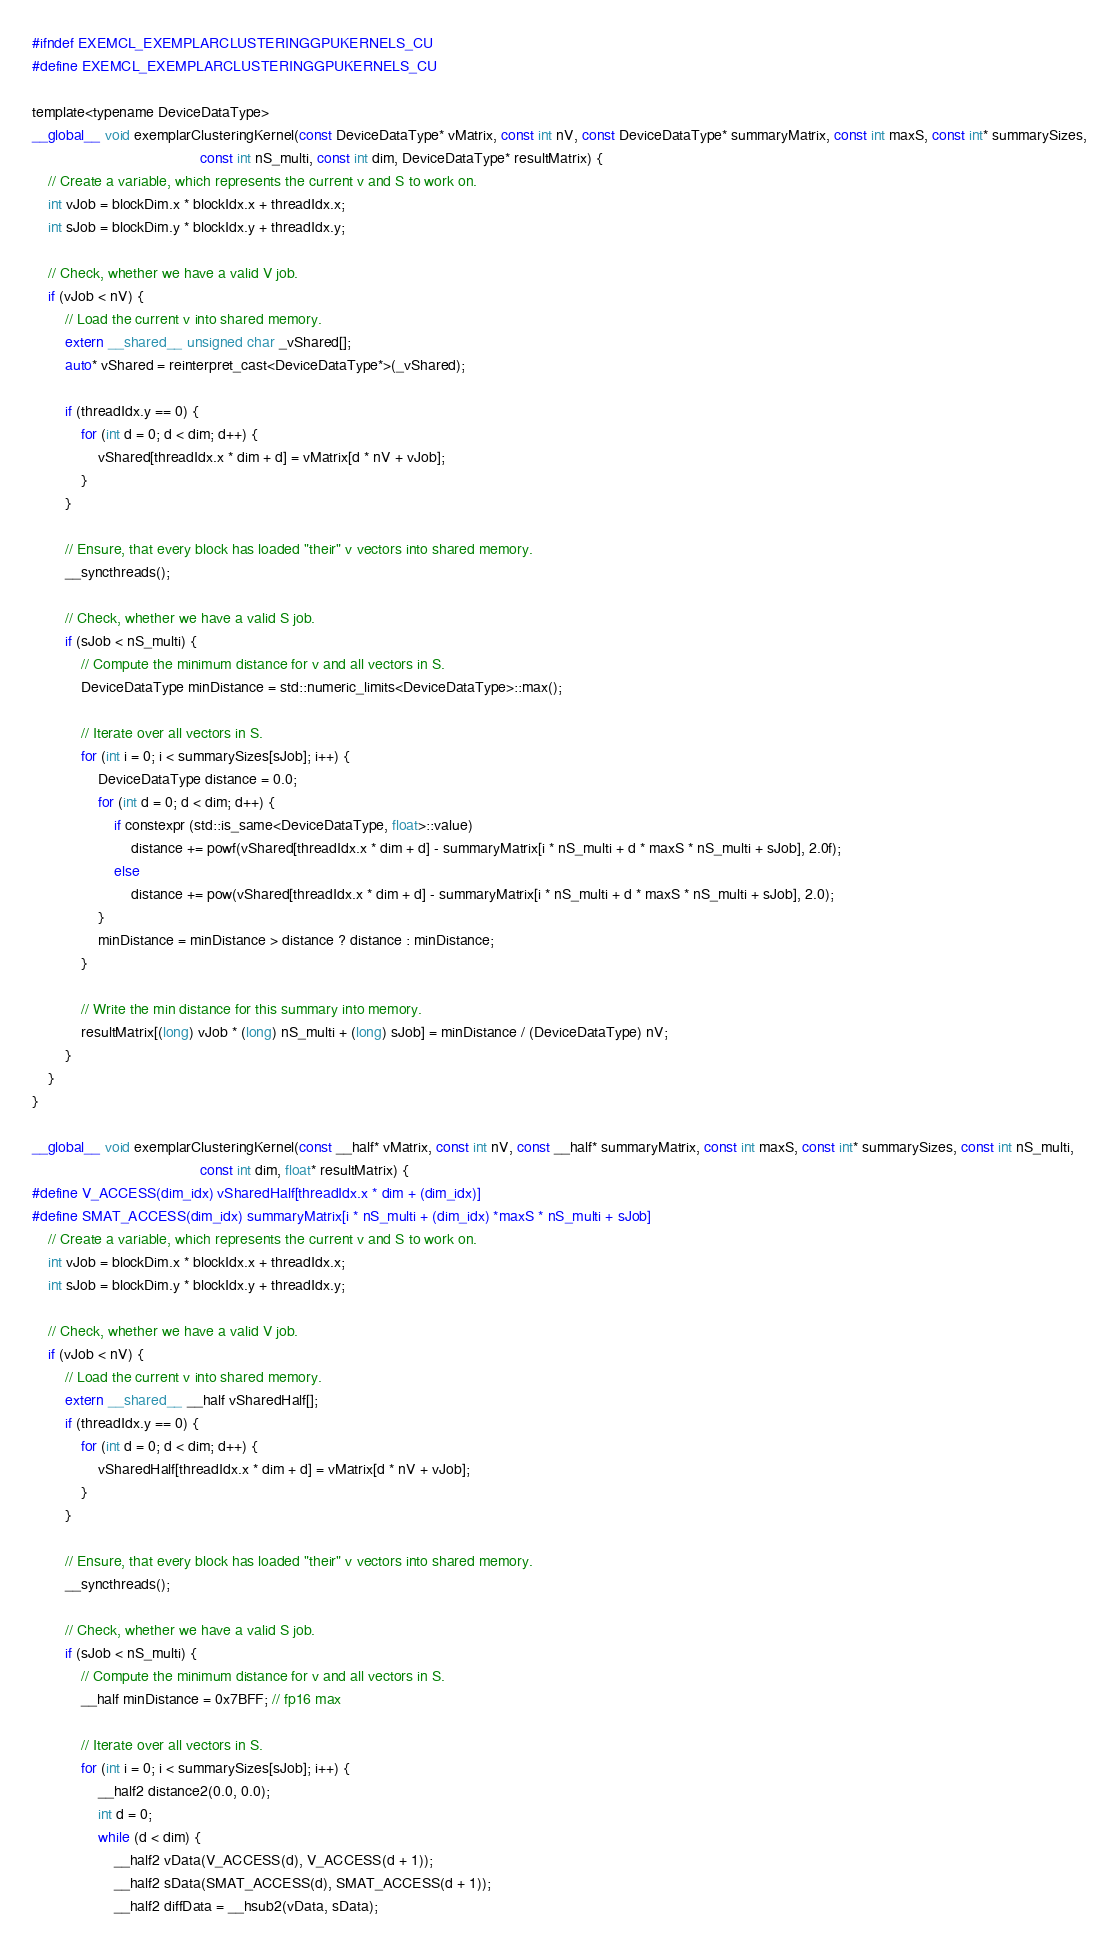<code> <loc_0><loc_0><loc_500><loc_500><_Cuda_>#ifndef EXEMCL_EXEMPLARCLUSTERINGGPUKERNELS_CU
#define EXEMCL_EXEMPLARCLUSTERINGGPUKERNELS_CU

template<typename DeviceDataType>
__global__ void exemplarClusteringKernel(const DeviceDataType* vMatrix, const int nV, const DeviceDataType* summaryMatrix, const int maxS, const int* summarySizes,
                                         const int nS_multi, const int dim, DeviceDataType* resultMatrix) {
    // Create a variable, which represents the current v and S to work on.
    int vJob = blockDim.x * blockIdx.x + threadIdx.x;
    int sJob = blockDim.y * blockIdx.y + threadIdx.y;

    // Check, whether we have a valid V job.
    if (vJob < nV) {
        // Load the current v into shared memory.
        extern __shared__ unsigned char _vShared[];
        auto* vShared = reinterpret_cast<DeviceDataType*>(_vShared);

        if (threadIdx.y == 0) {
            for (int d = 0; d < dim; d++) {
                vShared[threadIdx.x * dim + d] = vMatrix[d * nV + vJob];
            }
        }

        // Ensure, that every block has loaded "their" v vectors into shared memory.
        __syncthreads();

        // Check, whether we have a valid S job.
        if (sJob < nS_multi) {
            // Compute the minimum distance for v and all vectors in S.
            DeviceDataType minDistance = std::numeric_limits<DeviceDataType>::max();

            // Iterate over all vectors in S.
            for (int i = 0; i < summarySizes[sJob]; i++) {
                DeviceDataType distance = 0.0;
                for (int d = 0; d < dim; d++) {
                    if constexpr (std::is_same<DeviceDataType, float>::value)
                        distance += powf(vShared[threadIdx.x * dim + d] - summaryMatrix[i * nS_multi + d * maxS * nS_multi + sJob], 2.0f);
                    else
                        distance += pow(vShared[threadIdx.x * dim + d] - summaryMatrix[i * nS_multi + d * maxS * nS_multi + sJob], 2.0);
                }
                minDistance = minDistance > distance ? distance : minDistance;
            }

            // Write the min distance for this summary into memory.
            resultMatrix[(long) vJob * (long) nS_multi + (long) sJob] = minDistance / (DeviceDataType) nV;
        }
    }
}

__global__ void exemplarClusteringKernel(const __half* vMatrix, const int nV, const __half* summaryMatrix, const int maxS, const int* summarySizes, const int nS_multi,
                                         const int dim, float* resultMatrix) {
#define V_ACCESS(dim_idx) vSharedHalf[threadIdx.x * dim + (dim_idx)]
#define SMAT_ACCESS(dim_idx) summaryMatrix[i * nS_multi + (dim_idx) *maxS * nS_multi + sJob]
    // Create a variable, which represents the current v and S to work on.
    int vJob = blockDim.x * blockIdx.x + threadIdx.x;
    int sJob = blockDim.y * blockIdx.y + threadIdx.y;

    // Check, whether we have a valid V job.
    if (vJob < nV) {
        // Load the current v into shared memory.
        extern __shared__ __half vSharedHalf[];
        if (threadIdx.y == 0) {
            for (int d = 0; d < dim; d++) {
                vSharedHalf[threadIdx.x * dim + d] = vMatrix[d * nV + vJob];
            }
        }

        // Ensure, that every block has loaded "their" v vectors into shared memory.
        __syncthreads();

        // Check, whether we have a valid S job.
        if (sJob < nS_multi) {
            // Compute the minimum distance for v and all vectors in S.
            __half minDistance = 0x7BFF; // fp16 max

            // Iterate over all vectors in S.
            for (int i = 0; i < summarySizes[sJob]; i++) {
                __half2 distance2(0.0, 0.0);
                int d = 0;
                while (d < dim) {
                    __half2 vData(V_ACCESS(d), V_ACCESS(d + 1));
                    __half2 sData(SMAT_ACCESS(d), SMAT_ACCESS(d + 1));
                    __half2 diffData = __hsub2(vData, sData);</code> 